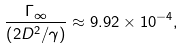Convert formula to latex. <formula><loc_0><loc_0><loc_500><loc_500>\frac { \Gamma _ { \infty } } { \left ( 2 D ^ { 2 } / \gamma \right ) } \approx 9 . 9 2 \times 1 0 ^ { - 4 } ,</formula> 